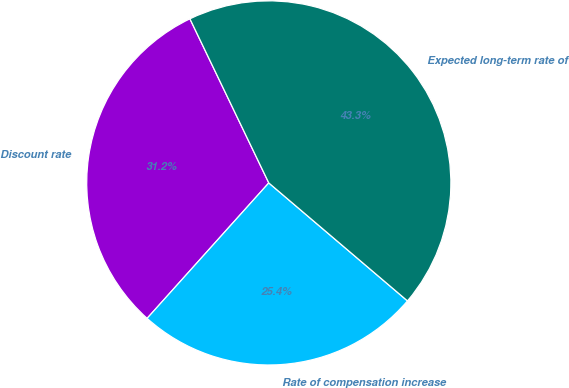<chart> <loc_0><loc_0><loc_500><loc_500><pie_chart><fcel>Discount rate<fcel>Rate of compensation increase<fcel>Expected long-term rate of<nl><fcel>31.22%<fcel>25.43%<fcel>43.35%<nl></chart> 